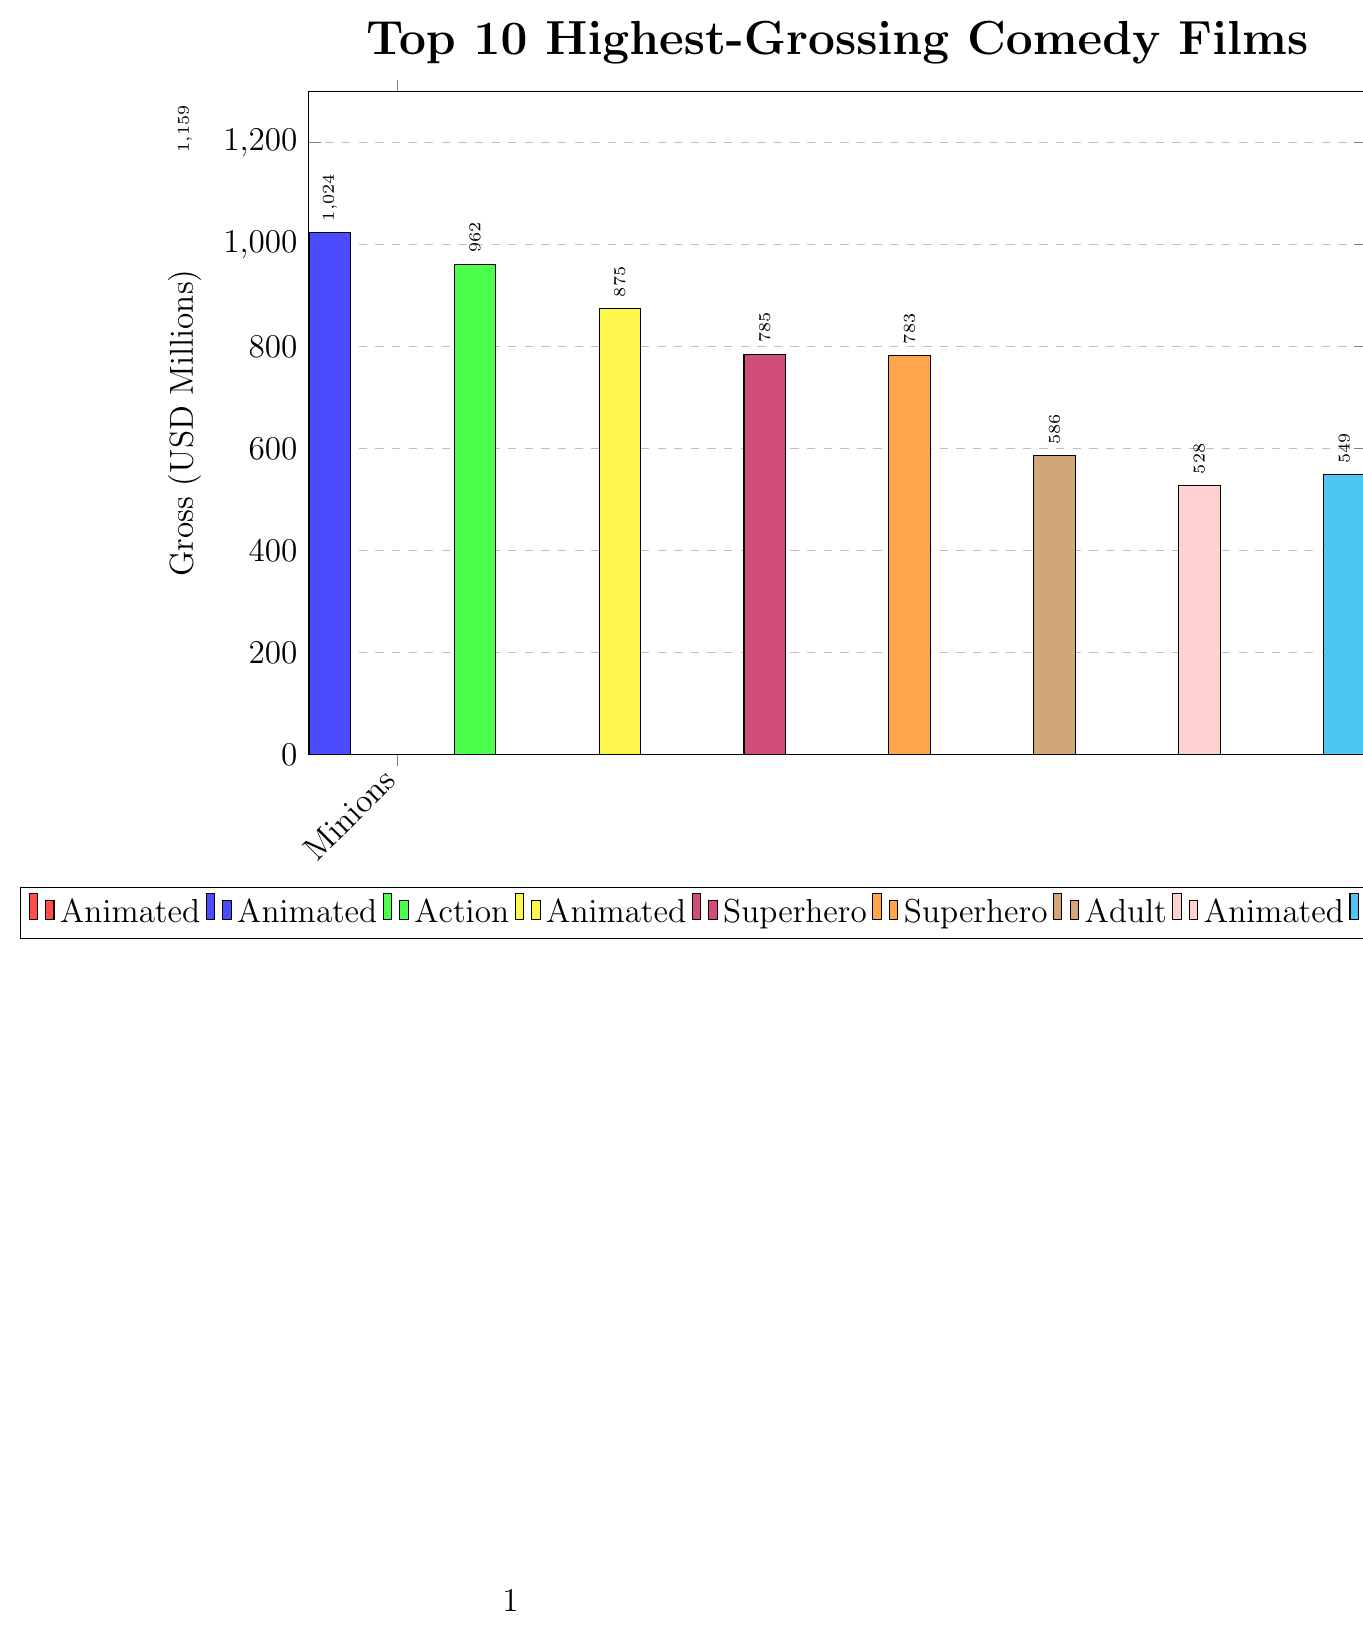Which film grossed the most among the top 10 highest-grossing comedy films? The film with the tallest bar indicates the highest grossing, and the bar associated with "Minions" is the tallest, indicating the highest gross of 1159 million USD.
Answer: Minions Which film grossed the least among the top 10 highest-grossing comedy films? The film with the shortest bar indicates the lowest grossing, and the bar associated with "The Lego Movie" is the shortest, indicating the lowest gross of 468 million USD.
Answer: The Lego Movie What is the combined gross of all the animated-comedy films in the top 10? Among the top 10, the animated-comedy films are "Minions" (1159 million), "Zootopia" (1024 million), "The Secret Life of Pets" (875 million), "The Boss Baby" (528 million), and "The Lego Movie" (468 million). Summing these gives 1159 + 1024 + 875 + 528 + 468 = 4054 million USD.
Answer: 4054 million USD Which subgenre has more films in the top 10: animated-comedy or superhero-comedy? From the legend and the x-axis labels, there are 5 animated-comedy films ("Minions," "Zootopia," "The Secret Life of Pets," "The Boss Baby," "The Lego Movie") and 2 superhero-comedy films ("Deadpool," "Deadpool 2"). Animated-comedy has more films in the top 10.
Answer: Animated-Comedy How does the gross of "Jumanji: Welcome to the Jungle" compare to "Deadpool 2"? The bar for "Jumanji: Welcome to the Jungle" is taller and reaches 962 million USD, whereas "Deadpool 2" is shorter and reaches 785 million USD. Thus, "Jumanji: Welcome to the Jungle" grossed more than "Deadpool 2".
Answer: Jumanji: Welcome to the Jungle grossed more What's the total gross for both "The Hangover Part II" and "Ted"? The gross for "The Hangover Part II" is 586 million USD, and for "Ted" is 549 million USD. Adding these together gives 586 + 549 = 1135 million USD.
Answer: 1135 million USD How much more did "Zootopia" gross compared to "Deadpool"? "Zootopia" grossed 1024 million USD and "Deadpool" grossed 783 million USD. The difference is 1024 - 783 = 241 million USD.
Answer: 241 million USD What is the average gross of the top 10 highest-grossing comedy films? Summing the gross of each of the top 10 comedy films (1159 + 1024 + 962 + 875 + 785 + 783 + 586 + 528 + 549 + 468) gives a total of 7719 million USD. Dividing this by 10 (number of films) gives 771.9 million USD.
Answer: 771.9 million USD Which subgenre has the highest-grossing film in the top 10? The highest-grossing film "Minions" belongs to the animated-comedy subgenre.
Answer: Animated-Comedy Which film has a gross closest to the median value of the top 10 highest-grossing films? Ordered Gross values: 468, 528, 549, 586, 783, 785, 875, 962, 1024, 1159. The median value is the average of the 5th and 6th values: (783 + 785)/2 = 784 million USD. "Deadpool 2" with a gross of 785 million USD is the closest to this median.
Answer: Deadpool 2 